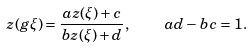<formula> <loc_0><loc_0><loc_500><loc_500>z ( g \xi ) = \frac { a z ( \xi ) + c } { b z ( \xi ) + d } , \quad a d - b c = 1 .</formula> 